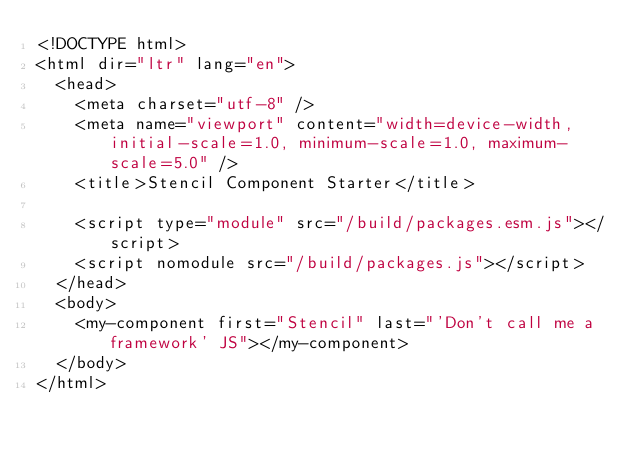<code> <loc_0><loc_0><loc_500><loc_500><_HTML_><!DOCTYPE html>
<html dir="ltr" lang="en">
  <head>
    <meta charset="utf-8" />
    <meta name="viewport" content="width=device-width, initial-scale=1.0, minimum-scale=1.0, maximum-scale=5.0" />
    <title>Stencil Component Starter</title>

    <script type="module" src="/build/packages.esm.js"></script>
    <script nomodule src="/build/packages.js"></script>
  </head>
  <body>
    <my-component first="Stencil" last="'Don't call me a framework' JS"></my-component>
  </body>
</html>
</code> 